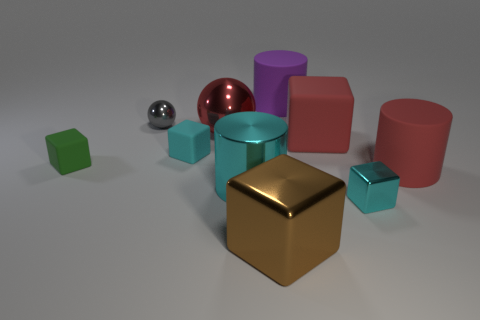How many cyan matte objects are the same shape as the small green object?
Your answer should be very brief. 1. There is a purple thing that is the same material as the red cube; what size is it?
Your answer should be very brief. Large. What color is the large thing that is both behind the big cyan metal object and on the left side of the large purple cylinder?
Keep it short and to the point. Red. What number of cyan matte objects are the same size as the cyan cylinder?
Make the answer very short. 0. The cylinder that is the same color as the large ball is what size?
Offer a very short reply. Large. What size is the metallic object that is in front of the big metallic cylinder and on the left side of the purple cylinder?
Your answer should be very brief. Large. How many red matte things are behind the small matte block that is left of the tiny metallic object that is behind the tiny green rubber block?
Your answer should be compact. 1. Is there a small metal thing that has the same color as the big metal cylinder?
Provide a short and direct response. Yes. The rubber block that is the same size as the red shiny thing is what color?
Provide a short and direct response. Red. There is a cyan thing that is behind the tiny rubber block left of the small cyan thing that is left of the small metal block; what is its shape?
Give a very brief answer. Cube. 